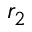<formula> <loc_0><loc_0><loc_500><loc_500>r _ { 2 }</formula> 